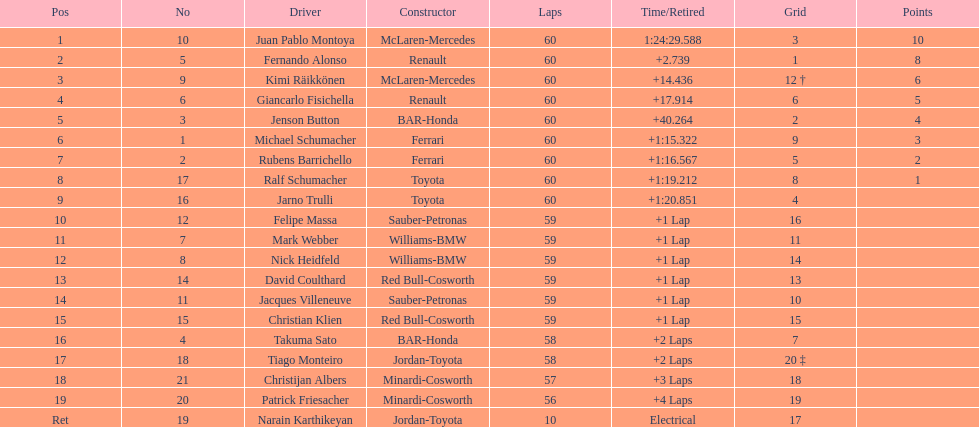How many german drivers? 3. 